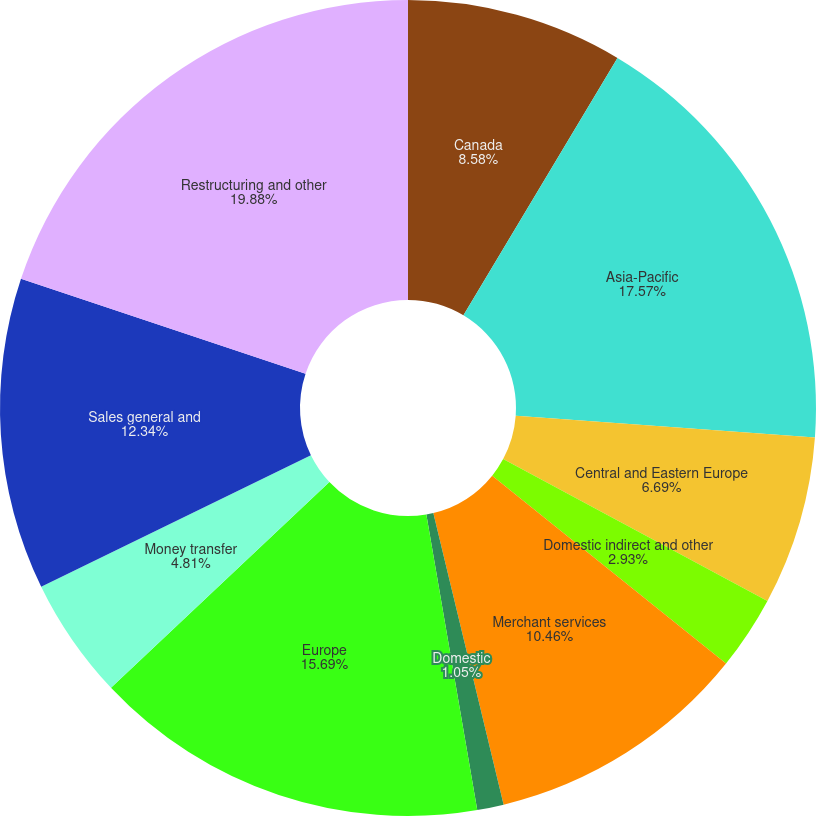<chart> <loc_0><loc_0><loc_500><loc_500><pie_chart><fcel>Canada<fcel>Asia-Pacific<fcel>Central and Eastern Europe<fcel>Domestic indirect and other<fcel>Merchant services<fcel>Domestic<fcel>Europe<fcel>Money transfer<fcel>Sales general and<fcel>Restructuring and other<nl><fcel>8.58%<fcel>17.57%<fcel>6.69%<fcel>2.93%<fcel>10.46%<fcel>1.05%<fcel>15.69%<fcel>4.81%<fcel>12.34%<fcel>19.87%<nl></chart> 